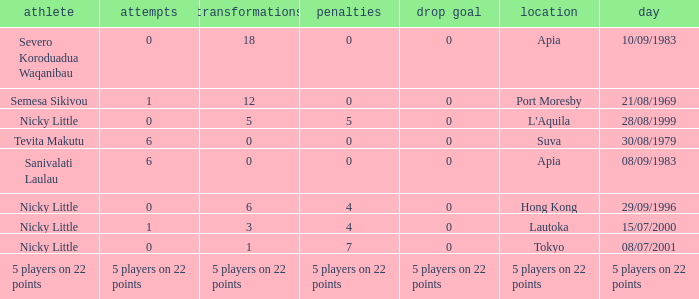How many conversions had 0 pens and 0 tries? 18.0. 